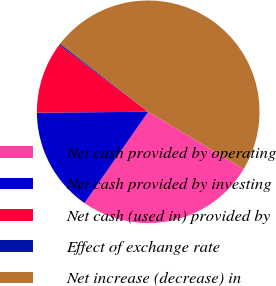Convert chart to OTSL. <chart><loc_0><loc_0><loc_500><loc_500><pie_chart><fcel>Net cash provided by operating<fcel>Net cash provided by investing<fcel>Net cash (used in) provided by<fcel>Effect of exchange rate<fcel>Net increase (decrease) in<nl><fcel>26.07%<fcel>15.18%<fcel>10.39%<fcel>0.2%<fcel>48.16%<nl></chart> 